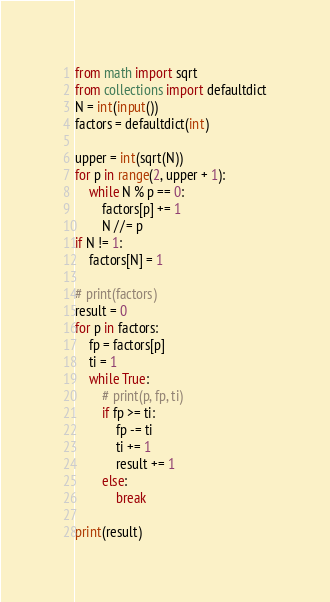Convert code to text. <code><loc_0><loc_0><loc_500><loc_500><_Python_>from math import sqrt
from collections import defaultdict
N = int(input())
factors = defaultdict(int)

upper = int(sqrt(N))
for p in range(2, upper + 1):
    while N % p == 0:
        factors[p] += 1
        N //= p
if N != 1:
    factors[N] = 1

# print(factors)
result = 0
for p in factors:
    fp = factors[p]
    ti = 1
    while True:
        # print(p, fp, ti)
        if fp >= ti:
            fp -= ti
            ti += 1
            result += 1
        else:
            break

print(result)
</code> 